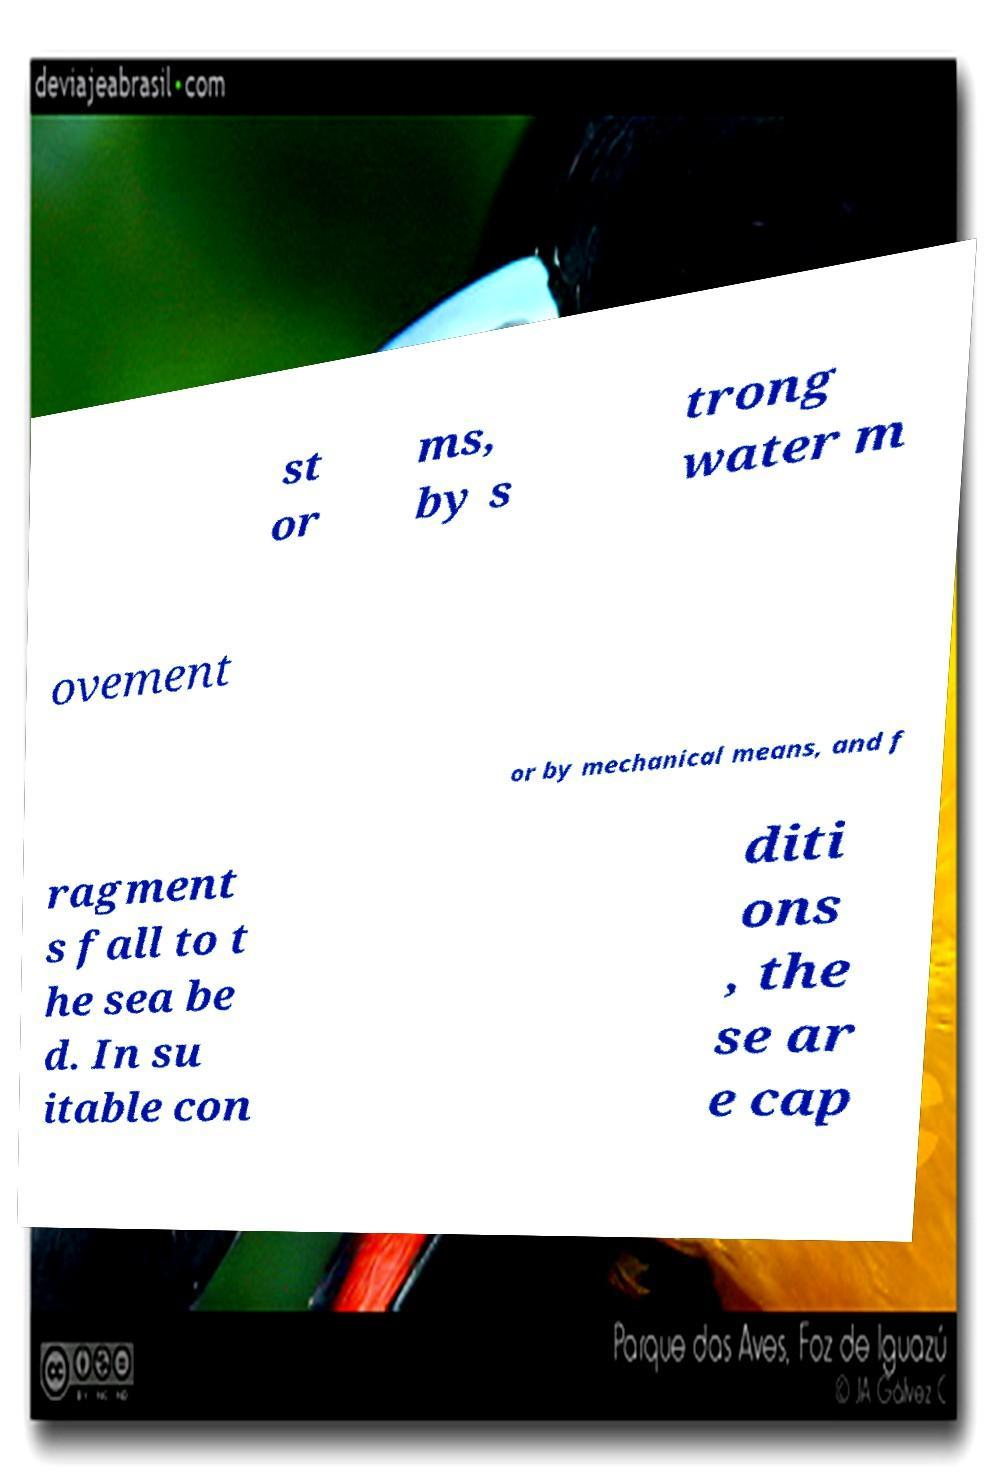Could you extract and type out the text from this image? st or ms, by s trong water m ovement or by mechanical means, and f ragment s fall to t he sea be d. In su itable con diti ons , the se ar e cap 